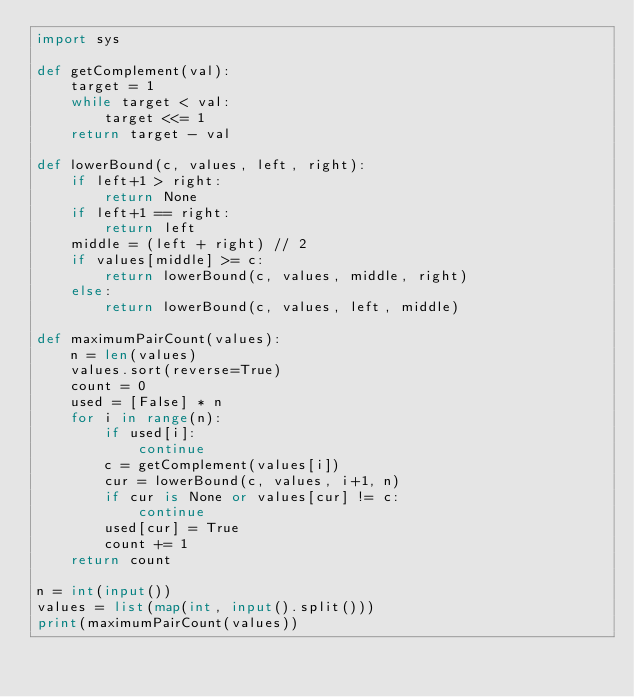Convert code to text. <code><loc_0><loc_0><loc_500><loc_500><_Python_>import sys

def getComplement(val):
	target = 1
	while target < val:
		target <<= 1
	return target - val

def lowerBound(c, values, left, right):
	if left+1 > right:
		return None
	if left+1 == right:
		return left
	middle = (left + right) // 2
	if values[middle] >= c:
		return lowerBound(c, values, middle, right)
	else:
		return lowerBound(c, values, left, middle)

def maximumPairCount(values):
	n = len(values)
	values.sort(reverse=True)
	count = 0
	used = [False] * n
	for i in range(n):
		if used[i]:
			continue
		c = getComplement(values[i])
		cur = lowerBound(c, values, i+1, n)
		if cur is None or values[cur] != c:
			continue
		used[cur] = True
		count += 1
	return count

n = int(input())
values = list(map(int, input().split()))
print(maximumPairCount(values))
</code> 